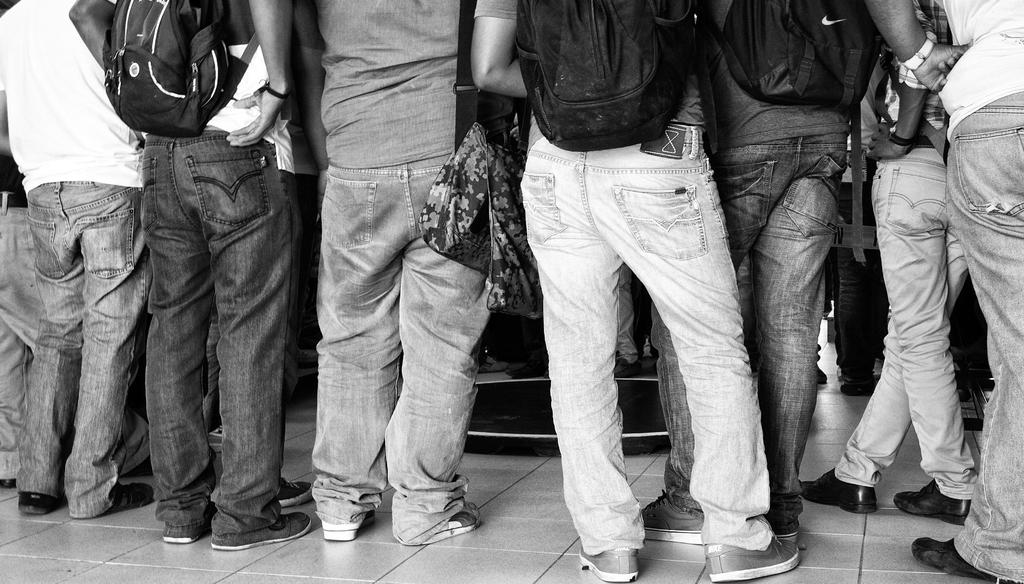What is the color scheme of the image? The image is black and white. What can be seen in the image besides the color scheme? There are groups of people standing on a path. Can you describe the position of one person in the image? Only one person's legs are visible in the image. What is the title of the book that the person is reading in the image? There is no book or person reading in the image; it only shows groups of people standing on a path. How far can the person swing their legs in the image? There is no person swinging their legs in the image; only one person's legs are visible. 